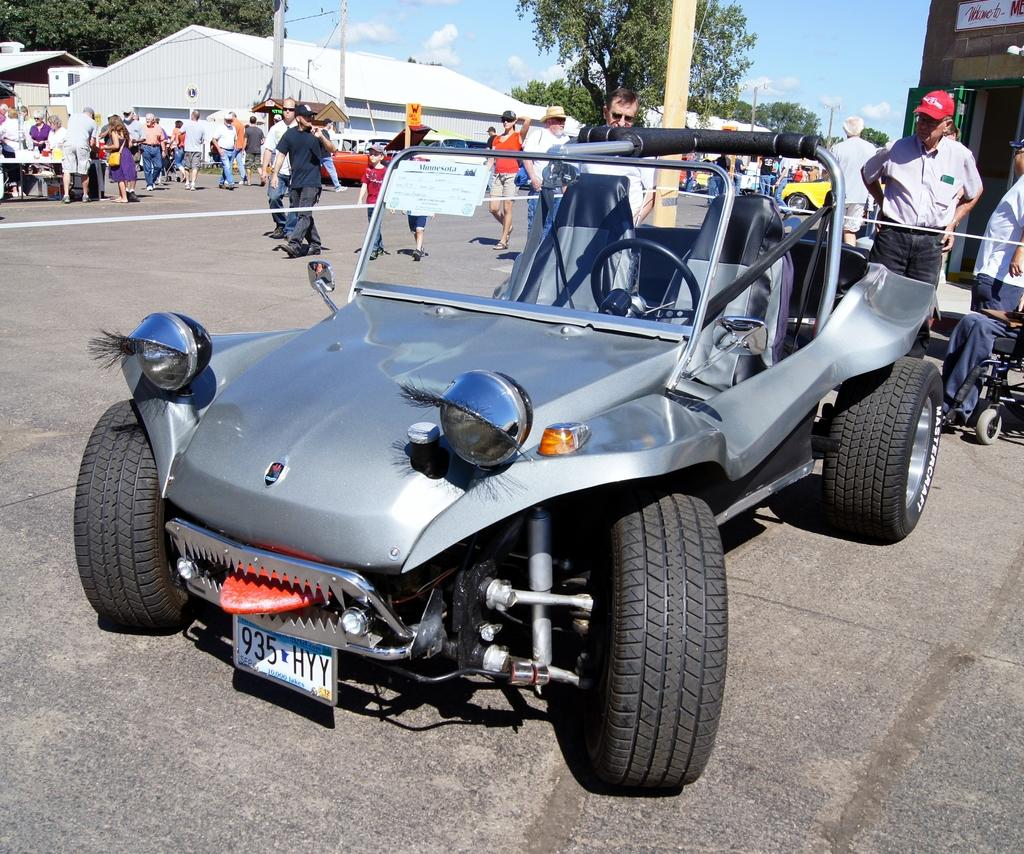Where was the image taken? The image was clicked outside. What can be seen at the top of the image? There are trees at the top of the image. What is located in the middle of the image? There are stores and a vehicle in the middle of the image. Are there any people visible in the image? Yes, there are people in the middle of the image. How many chairs are visible in the image? There are no chairs present in the image. What type of box is being used by the people in the image? There is no box present in the image. 